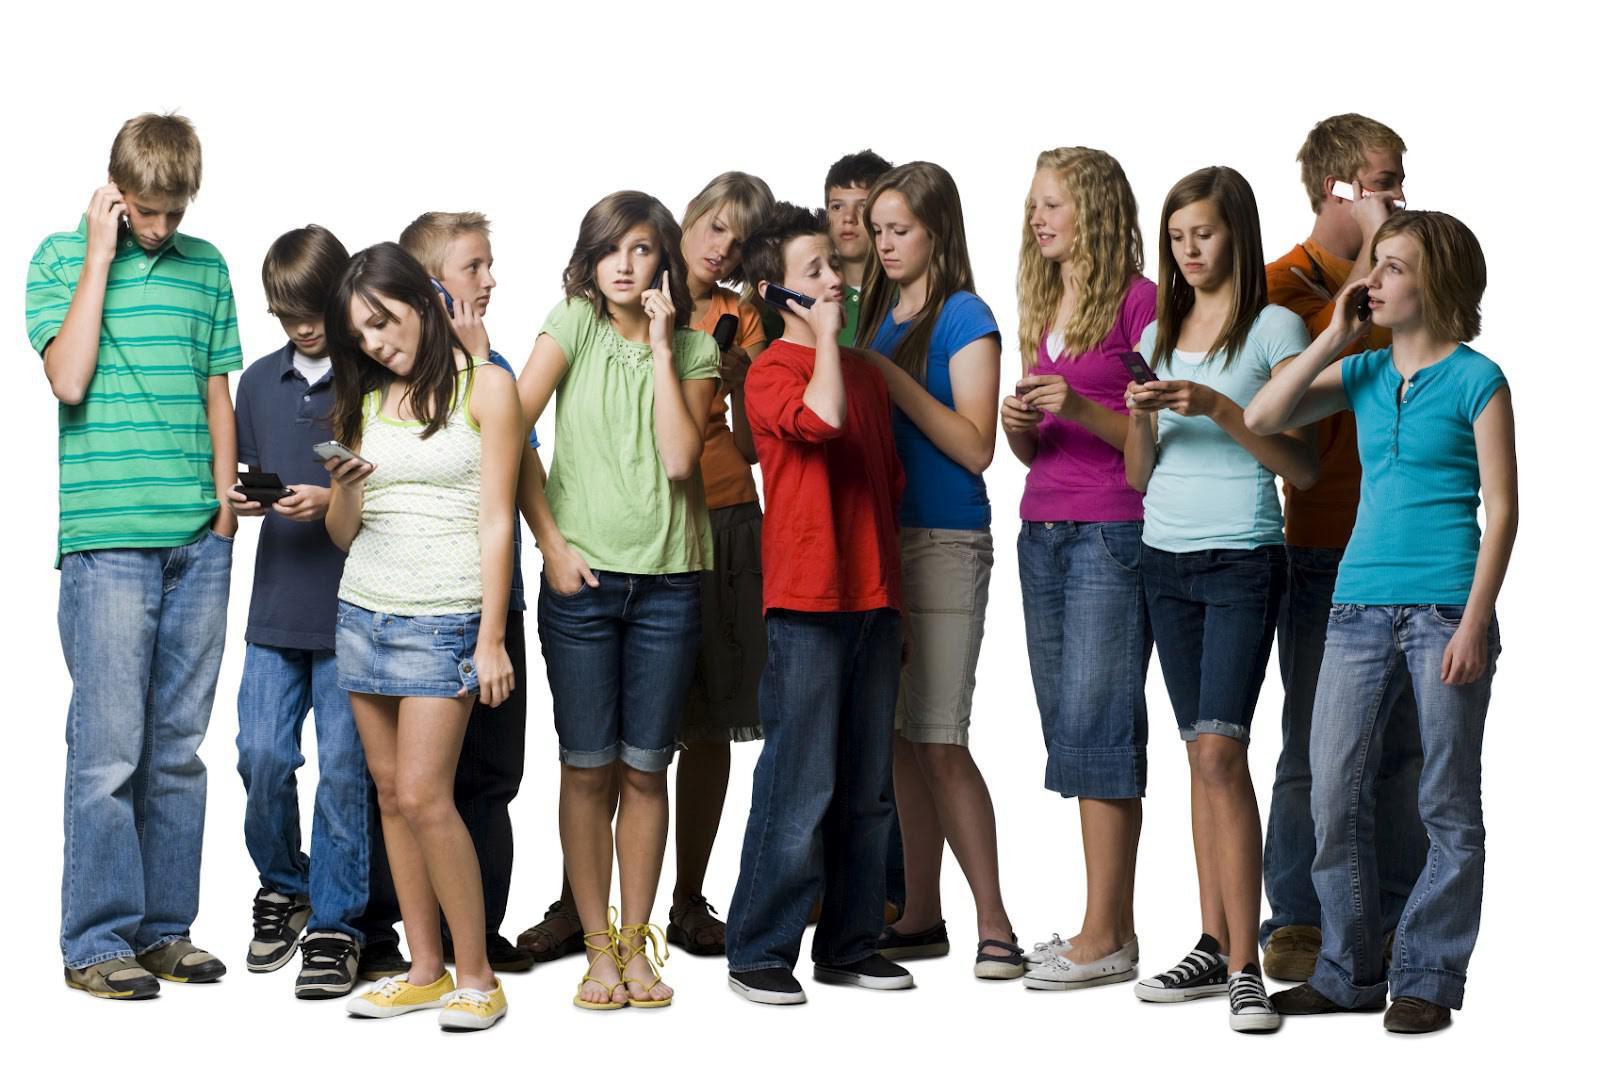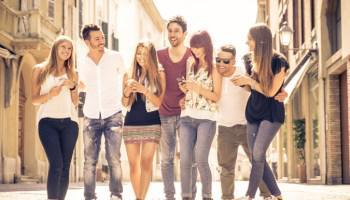The first image is the image on the left, the second image is the image on the right. Assess this claim about the two images: "An image shows four people standing in a line in front of a brick wall checking their phones.". Correct or not? Answer yes or no. No. The first image is the image on the left, the second image is the image on the right. Assess this claim about the two images: "In the right image people are talking on their phones.". Correct or not? Answer yes or no. No. 